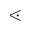Convert formula to latex. <formula><loc_0><loc_0><loc_500><loc_500>\leq s s d o t</formula> 